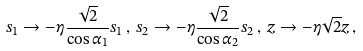Convert formula to latex. <formula><loc_0><loc_0><loc_500><loc_500>s _ { 1 } \rightarrow - \eta \frac { \sqrt { 2 } } { \cos \alpha _ { 1 } } s _ { 1 } \, , \, s _ { 2 } \rightarrow - \eta \frac { \sqrt { 2 } } { \cos \alpha _ { 2 } } s _ { 2 } \, , \, z \rightarrow - \eta \sqrt { 2 } z \, ,</formula> 